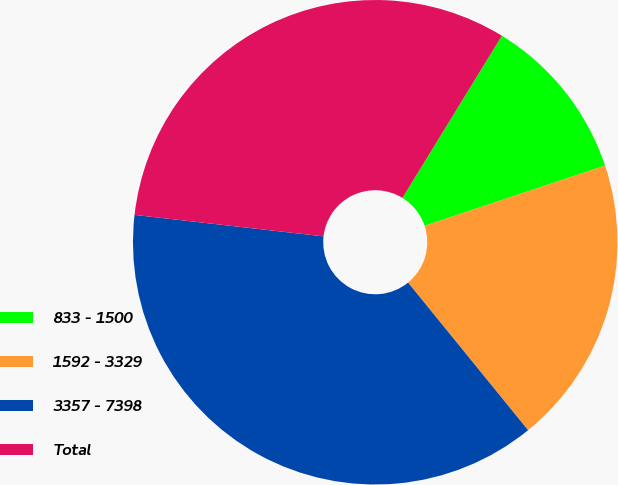Convert chart to OTSL. <chart><loc_0><loc_0><loc_500><loc_500><pie_chart><fcel>833 - 1500<fcel>1592 - 3329<fcel>3357 - 7398<fcel>Total<nl><fcel>11.12%<fcel>19.26%<fcel>37.67%<fcel>31.96%<nl></chart> 